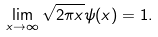<formula> <loc_0><loc_0><loc_500><loc_500>\lim _ { x \to \infty } \sqrt { 2 \pi x } \psi ( x ) = 1 .</formula> 